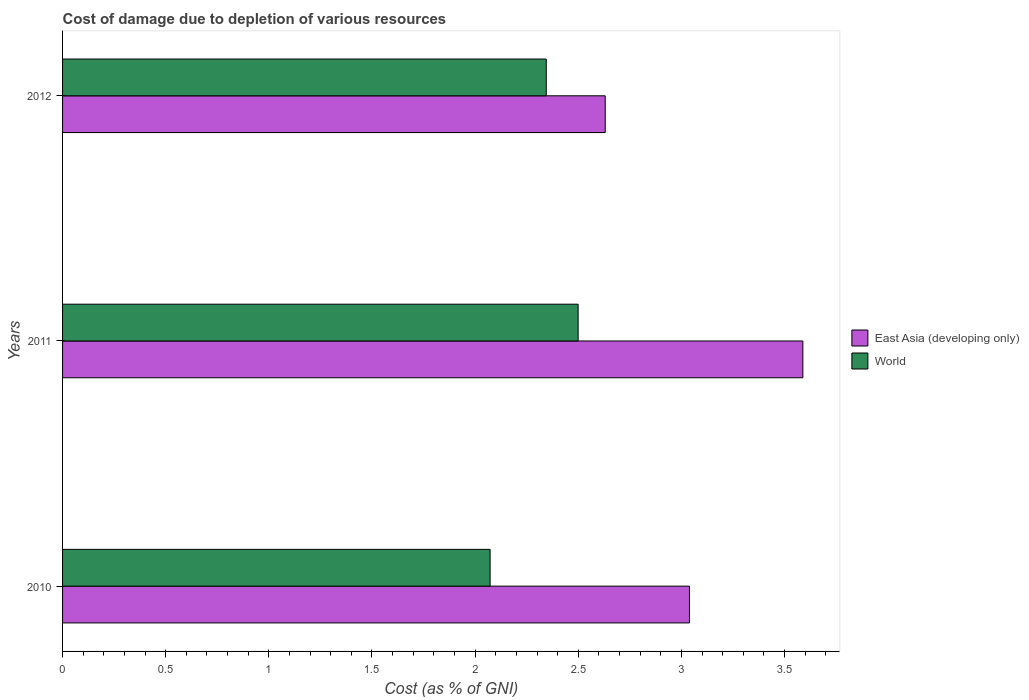How many groups of bars are there?
Provide a succinct answer. 3. Are the number of bars on each tick of the Y-axis equal?
Provide a succinct answer. Yes. What is the label of the 2nd group of bars from the top?
Give a very brief answer. 2011. In how many cases, is the number of bars for a given year not equal to the number of legend labels?
Make the answer very short. 0. What is the cost of damage caused due to the depletion of various resources in World in 2010?
Make the answer very short. 2.07. Across all years, what is the maximum cost of damage caused due to the depletion of various resources in World?
Offer a very short reply. 2.5. Across all years, what is the minimum cost of damage caused due to the depletion of various resources in World?
Keep it short and to the point. 2.07. In which year was the cost of damage caused due to the depletion of various resources in World maximum?
Provide a succinct answer. 2011. In which year was the cost of damage caused due to the depletion of various resources in East Asia (developing only) minimum?
Provide a succinct answer. 2012. What is the total cost of damage caused due to the depletion of various resources in East Asia (developing only) in the graph?
Offer a terse response. 9.26. What is the difference between the cost of damage caused due to the depletion of various resources in East Asia (developing only) in 2010 and that in 2012?
Your answer should be compact. 0.41. What is the difference between the cost of damage caused due to the depletion of various resources in East Asia (developing only) in 2011 and the cost of damage caused due to the depletion of various resources in World in 2012?
Give a very brief answer. 1.24. What is the average cost of damage caused due to the depletion of various resources in East Asia (developing only) per year?
Your answer should be very brief. 3.09. In the year 2011, what is the difference between the cost of damage caused due to the depletion of various resources in East Asia (developing only) and cost of damage caused due to the depletion of various resources in World?
Make the answer very short. 1.09. What is the ratio of the cost of damage caused due to the depletion of various resources in World in 2011 to that in 2012?
Your response must be concise. 1.07. Is the cost of damage caused due to the depletion of various resources in World in 2010 less than that in 2012?
Your response must be concise. Yes. Is the difference between the cost of damage caused due to the depletion of various resources in East Asia (developing only) in 2010 and 2011 greater than the difference between the cost of damage caused due to the depletion of various resources in World in 2010 and 2011?
Your answer should be very brief. No. What is the difference between the highest and the second highest cost of damage caused due to the depletion of various resources in East Asia (developing only)?
Offer a very short reply. 0.55. What is the difference between the highest and the lowest cost of damage caused due to the depletion of various resources in East Asia (developing only)?
Your answer should be compact. 0.96. Is the sum of the cost of damage caused due to the depletion of various resources in World in 2010 and 2011 greater than the maximum cost of damage caused due to the depletion of various resources in East Asia (developing only) across all years?
Your answer should be compact. Yes. What does the 2nd bar from the top in 2012 represents?
Give a very brief answer. East Asia (developing only). What does the 2nd bar from the bottom in 2011 represents?
Your answer should be very brief. World. Are all the bars in the graph horizontal?
Provide a succinct answer. Yes. How many years are there in the graph?
Offer a very short reply. 3. Are the values on the major ticks of X-axis written in scientific E-notation?
Give a very brief answer. No. Does the graph contain grids?
Your answer should be compact. No. Where does the legend appear in the graph?
Provide a short and direct response. Center right. How are the legend labels stacked?
Provide a short and direct response. Vertical. What is the title of the graph?
Keep it short and to the point. Cost of damage due to depletion of various resources. Does "Uruguay" appear as one of the legend labels in the graph?
Keep it short and to the point. No. What is the label or title of the X-axis?
Offer a terse response. Cost (as % of GNI). What is the label or title of the Y-axis?
Your answer should be compact. Years. What is the Cost (as % of GNI) in East Asia (developing only) in 2010?
Offer a terse response. 3.04. What is the Cost (as % of GNI) of World in 2010?
Ensure brevity in your answer.  2.07. What is the Cost (as % of GNI) in East Asia (developing only) in 2011?
Your answer should be very brief. 3.59. What is the Cost (as % of GNI) of World in 2011?
Provide a short and direct response. 2.5. What is the Cost (as % of GNI) in East Asia (developing only) in 2012?
Provide a succinct answer. 2.63. What is the Cost (as % of GNI) of World in 2012?
Provide a succinct answer. 2.34. Across all years, what is the maximum Cost (as % of GNI) of East Asia (developing only)?
Your answer should be compact. 3.59. Across all years, what is the maximum Cost (as % of GNI) in World?
Offer a very short reply. 2.5. Across all years, what is the minimum Cost (as % of GNI) in East Asia (developing only)?
Your answer should be compact. 2.63. Across all years, what is the minimum Cost (as % of GNI) of World?
Your answer should be compact. 2.07. What is the total Cost (as % of GNI) in East Asia (developing only) in the graph?
Offer a terse response. 9.26. What is the total Cost (as % of GNI) in World in the graph?
Provide a short and direct response. 6.92. What is the difference between the Cost (as % of GNI) of East Asia (developing only) in 2010 and that in 2011?
Make the answer very short. -0.55. What is the difference between the Cost (as % of GNI) of World in 2010 and that in 2011?
Ensure brevity in your answer.  -0.43. What is the difference between the Cost (as % of GNI) in East Asia (developing only) in 2010 and that in 2012?
Offer a very short reply. 0.41. What is the difference between the Cost (as % of GNI) in World in 2010 and that in 2012?
Keep it short and to the point. -0.27. What is the difference between the Cost (as % of GNI) in East Asia (developing only) in 2011 and that in 2012?
Offer a very short reply. 0.96. What is the difference between the Cost (as % of GNI) of World in 2011 and that in 2012?
Make the answer very short. 0.15. What is the difference between the Cost (as % of GNI) in East Asia (developing only) in 2010 and the Cost (as % of GNI) in World in 2011?
Your response must be concise. 0.54. What is the difference between the Cost (as % of GNI) of East Asia (developing only) in 2010 and the Cost (as % of GNI) of World in 2012?
Your answer should be very brief. 0.69. What is the difference between the Cost (as % of GNI) in East Asia (developing only) in 2011 and the Cost (as % of GNI) in World in 2012?
Your response must be concise. 1.24. What is the average Cost (as % of GNI) in East Asia (developing only) per year?
Your answer should be compact. 3.09. What is the average Cost (as % of GNI) in World per year?
Ensure brevity in your answer.  2.31. In the year 2010, what is the difference between the Cost (as % of GNI) in East Asia (developing only) and Cost (as % of GNI) in World?
Offer a very short reply. 0.97. In the year 2011, what is the difference between the Cost (as % of GNI) in East Asia (developing only) and Cost (as % of GNI) in World?
Your response must be concise. 1.09. In the year 2012, what is the difference between the Cost (as % of GNI) in East Asia (developing only) and Cost (as % of GNI) in World?
Keep it short and to the point. 0.29. What is the ratio of the Cost (as % of GNI) of East Asia (developing only) in 2010 to that in 2011?
Keep it short and to the point. 0.85. What is the ratio of the Cost (as % of GNI) in World in 2010 to that in 2011?
Provide a short and direct response. 0.83. What is the ratio of the Cost (as % of GNI) in East Asia (developing only) in 2010 to that in 2012?
Ensure brevity in your answer.  1.16. What is the ratio of the Cost (as % of GNI) in World in 2010 to that in 2012?
Keep it short and to the point. 0.88. What is the ratio of the Cost (as % of GNI) of East Asia (developing only) in 2011 to that in 2012?
Your answer should be compact. 1.36. What is the ratio of the Cost (as % of GNI) of World in 2011 to that in 2012?
Your answer should be very brief. 1.07. What is the difference between the highest and the second highest Cost (as % of GNI) of East Asia (developing only)?
Your answer should be compact. 0.55. What is the difference between the highest and the second highest Cost (as % of GNI) in World?
Provide a succinct answer. 0.15. What is the difference between the highest and the lowest Cost (as % of GNI) of East Asia (developing only)?
Provide a succinct answer. 0.96. What is the difference between the highest and the lowest Cost (as % of GNI) in World?
Your answer should be compact. 0.43. 